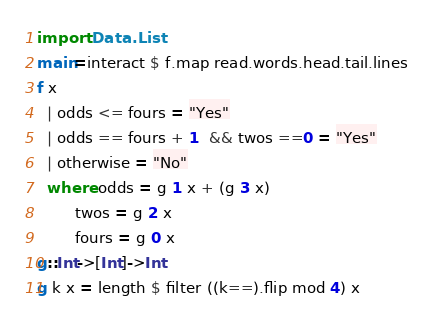<code> <loc_0><loc_0><loc_500><loc_500><_Haskell_>import Data.List
main=interact $ f.map read.words.head.tail.lines
f x 
  | odds <= fours = "Yes"
  | odds == fours + 1  && twos ==0 = "Yes"
  | otherwise = "No"
  where odds = g 1 x + (g 3 x)
        twos = g 2 x
        fours = g 0 x
g::Int->[Int]->Int
g k x = length $ filter ((k==).flip mod 4) x</code> 